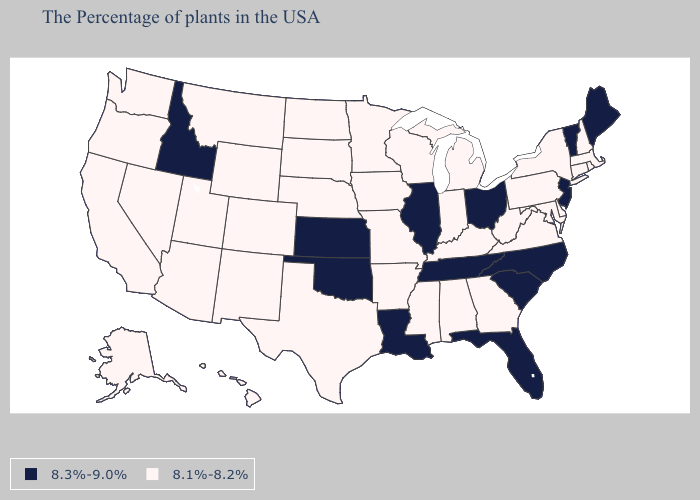Does Arkansas have the same value as Illinois?
Give a very brief answer. No. Does Iowa have the highest value in the USA?
Keep it brief. No. Among the states that border Oklahoma , which have the lowest value?
Give a very brief answer. Missouri, Arkansas, Texas, Colorado, New Mexico. Is the legend a continuous bar?
Short answer required. No. Name the states that have a value in the range 8.3%-9.0%?
Keep it brief. Maine, Vermont, New Jersey, North Carolina, South Carolina, Ohio, Florida, Tennessee, Illinois, Louisiana, Kansas, Oklahoma, Idaho. Name the states that have a value in the range 8.1%-8.2%?
Give a very brief answer. Massachusetts, Rhode Island, New Hampshire, Connecticut, New York, Delaware, Maryland, Pennsylvania, Virginia, West Virginia, Georgia, Michigan, Kentucky, Indiana, Alabama, Wisconsin, Mississippi, Missouri, Arkansas, Minnesota, Iowa, Nebraska, Texas, South Dakota, North Dakota, Wyoming, Colorado, New Mexico, Utah, Montana, Arizona, Nevada, California, Washington, Oregon, Alaska, Hawaii. What is the lowest value in the South?
Give a very brief answer. 8.1%-8.2%. What is the value of North Carolina?
Write a very short answer. 8.3%-9.0%. What is the value of Oklahoma?
Be succinct. 8.3%-9.0%. Name the states that have a value in the range 8.3%-9.0%?
Give a very brief answer. Maine, Vermont, New Jersey, North Carolina, South Carolina, Ohio, Florida, Tennessee, Illinois, Louisiana, Kansas, Oklahoma, Idaho. Does Wyoming have the highest value in the West?
Keep it brief. No. Does Rhode Island have the same value as California?
Write a very short answer. Yes. What is the value of Georgia?
Keep it brief. 8.1%-8.2%. Name the states that have a value in the range 8.1%-8.2%?
Write a very short answer. Massachusetts, Rhode Island, New Hampshire, Connecticut, New York, Delaware, Maryland, Pennsylvania, Virginia, West Virginia, Georgia, Michigan, Kentucky, Indiana, Alabama, Wisconsin, Mississippi, Missouri, Arkansas, Minnesota, Iowa, Nebraska, Texas, South Dakota, North Dakota, Wyoming, Colorado, New Mexico, Utah, Montana, Arizona, Nevada, California, Washington, Oregon, Alaska, Hawaii. Among the states that border Montana , does Idaho have the lowest value?
Keep it brief. No. 